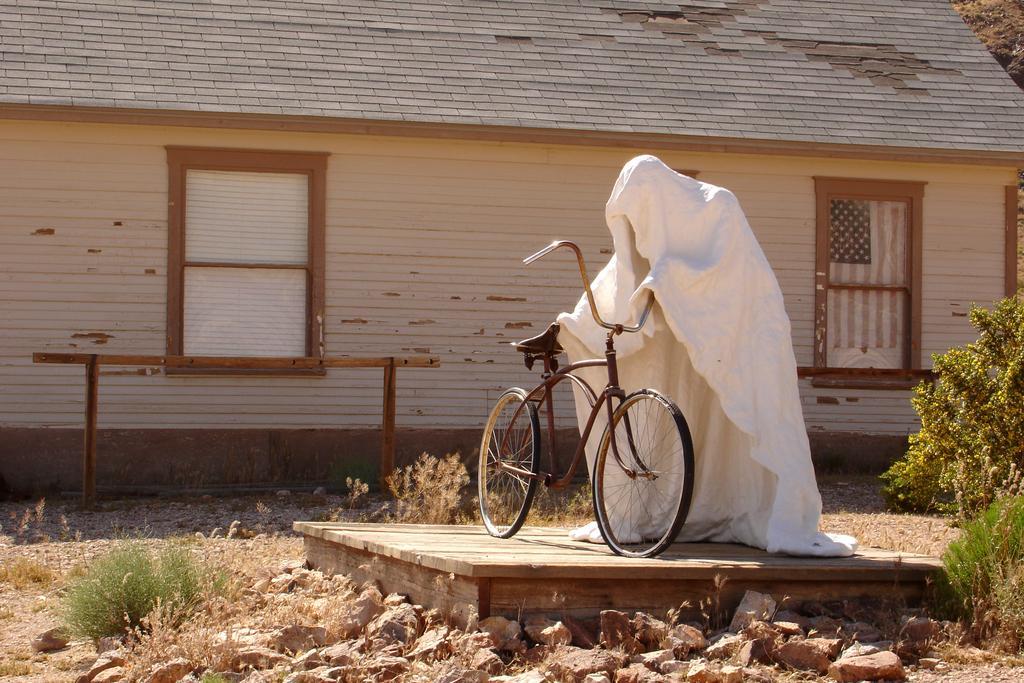Could you give a brief overview of what you see in this image? On the right side, there is a bicycle parked. Beside this bicycle, there is a white colored cloth arranged like a person on a stage. On the right side, there are plants, grass and stones on the ground. On the left side, there are plants, grass and stones on the ground. In the background, there is a building which is having windows and roof and there is a tree. 